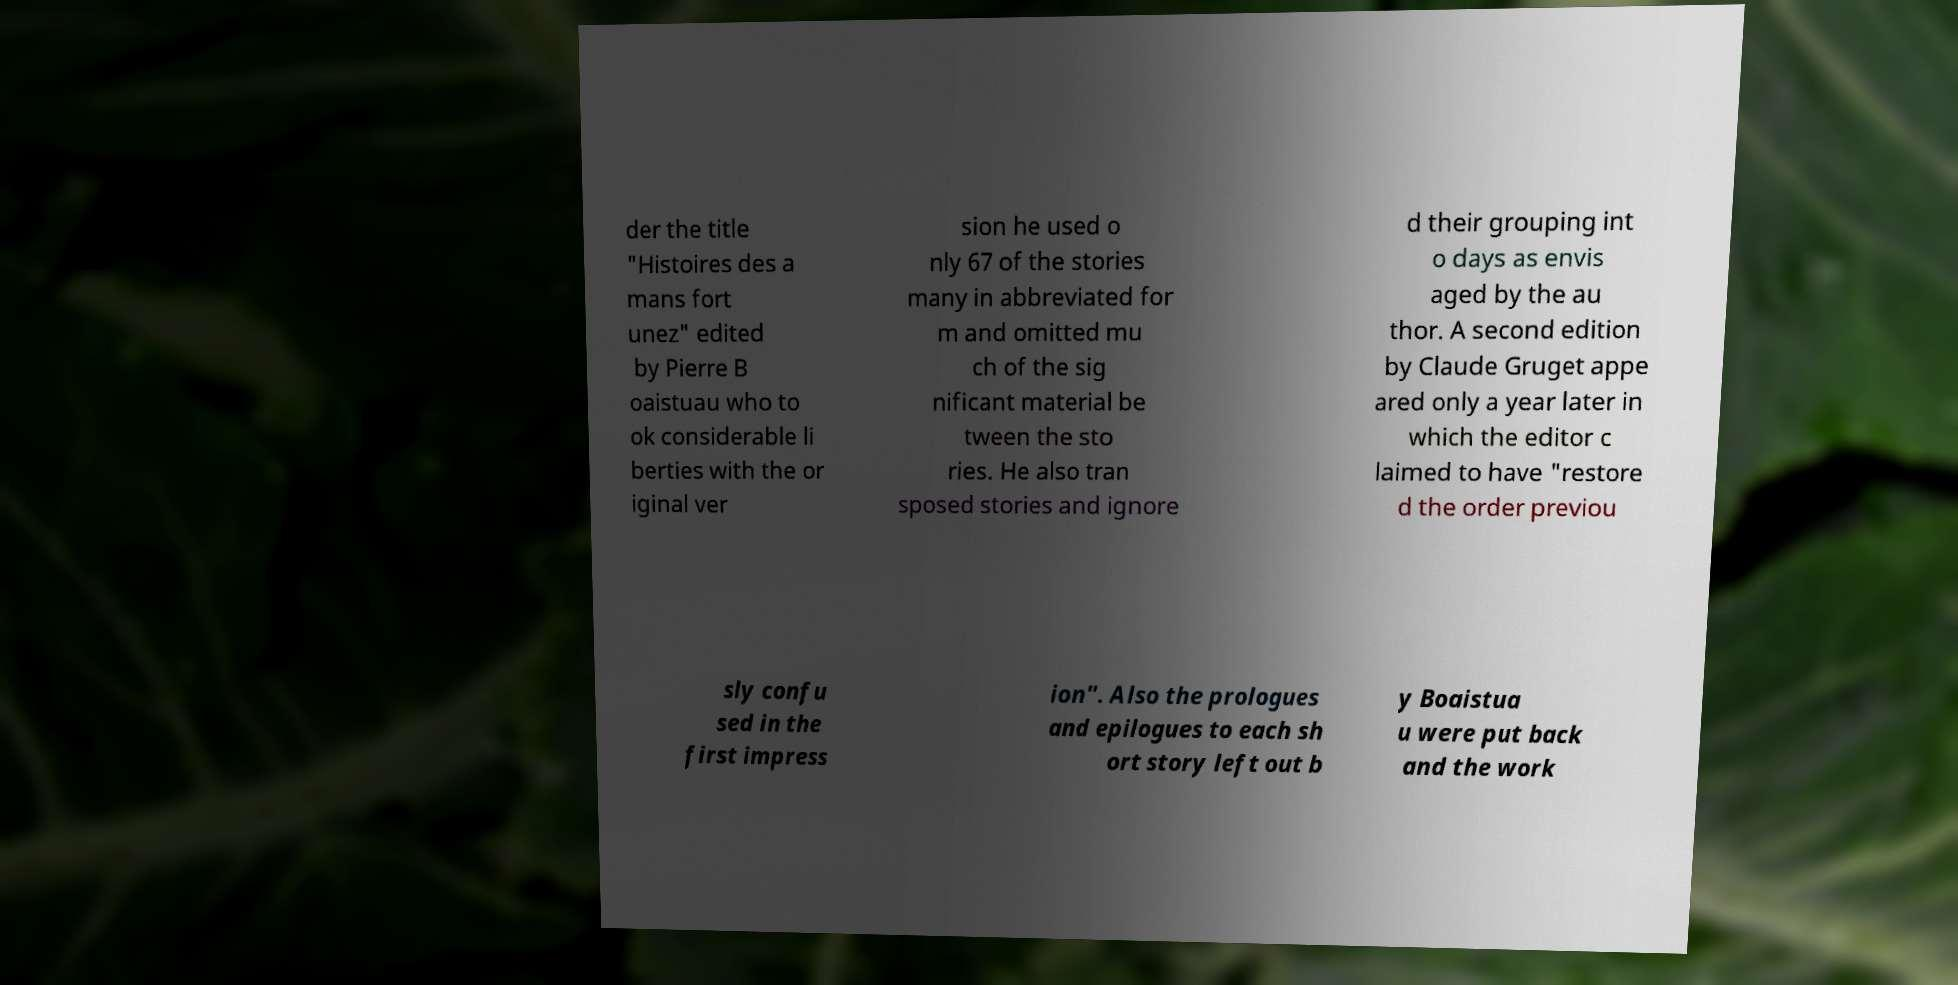Please read and relay the text visible in this image. What does it say? der the title "Histoires des a mans fort unez" edited by Pierre B oaistuau who to ok considerable li berties with the or iginal ver sion he used o nly 67 of the stories many in abbreviated for m and omitted mu ch of the sig nificant material be tween the sto ries. He also tran sposed stories and ignore d their grouping int o days as envis aged by the au thor. A second edition by Claude Gruget appe ared only a year later in which the editor c laimed to have "restore d the order previou sly confu sed in the first impress ion". Also the prologues and epilogues to each sh ort story left out b y Boaistua u were put back and the work 